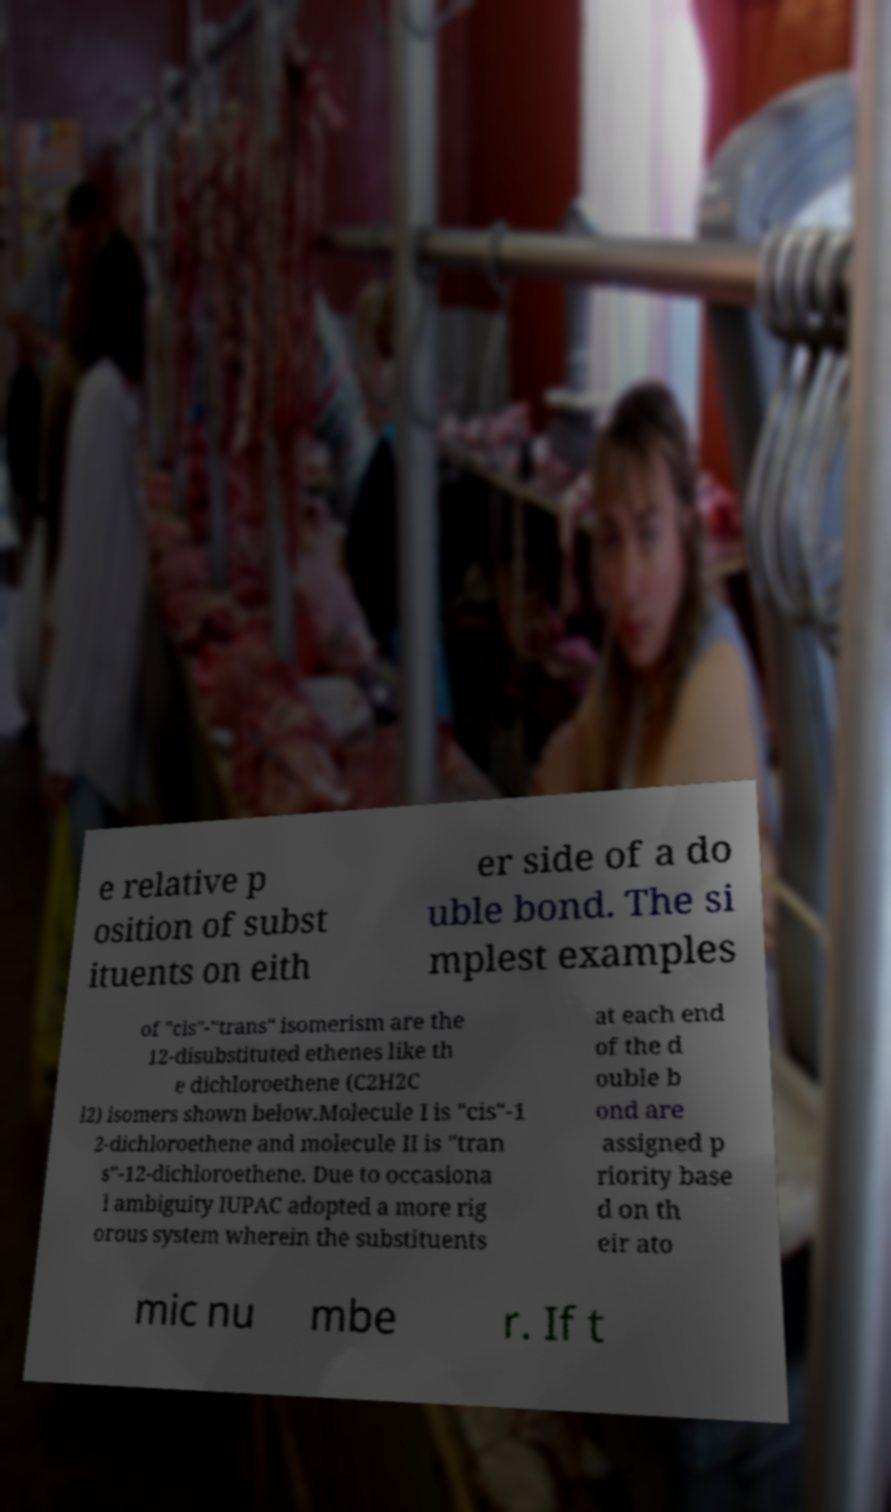Can you read and provide the text displayed in the image?This photo seems to have some interesting text. Can you extract and type it out for me? e relative p osition of subst ituents on eith er side of a do uble bond. The si mplest examples of "cis"-"trans" isomerism are the 12-disubstituted ethenes like th e dichloroethene (C2H2C l2) isomers shown below.Molecule I is "cis"-1 2-dichloroethene and molecule II is "tran s"-12-dichloroethene. Due to occasiona l ambiguity IUPAC adopted a more rig orous system wherein the substituents at each end of the d ouble b ond are assigned p riority base d on th eir ato mic nu mbe r. If t 